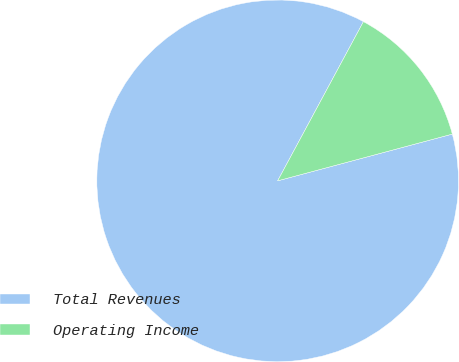<chart> <loc_0><loc_0><loc_500><loc_500><pie_chart><fcel>Total Revenues<fcel>Operating Income<nl><fcel>87.03%<fcel>12.97%<nl></chart> 